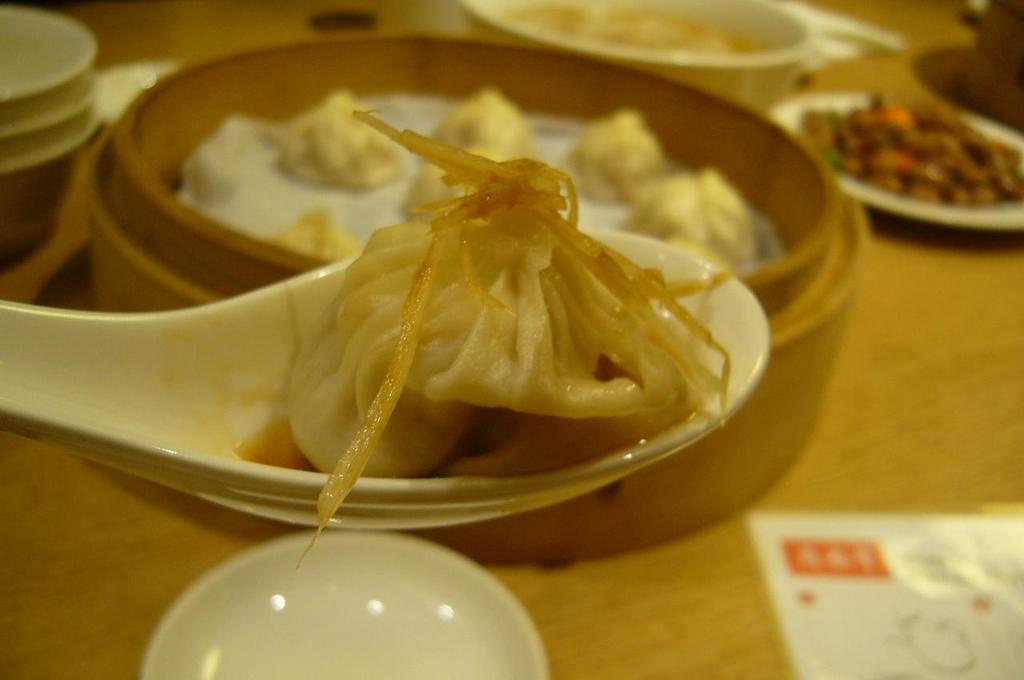What can be seen in the bowls in the image? There are food items in the bowls in the image. What is on the table in the image? There is a paper on the table in the image. How is one of the food items being served in the image? There is a food item on a spoon in the image. How many girls are smashing wood in the image? There are no girls or wood present in the image. 